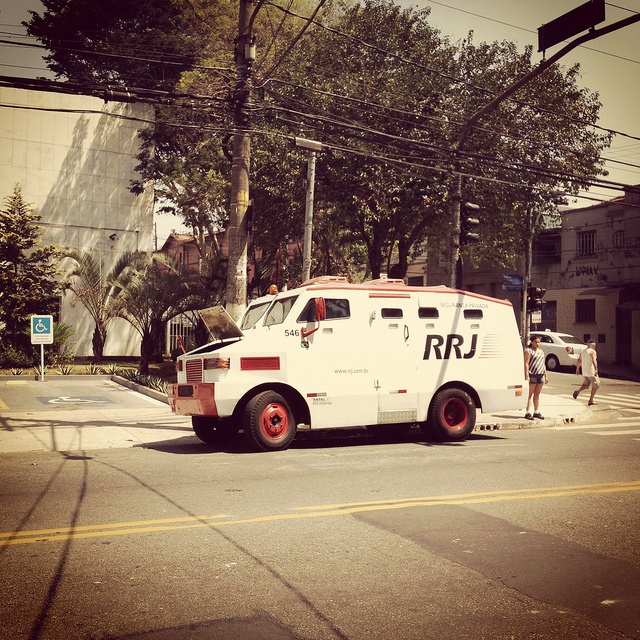Describe the objects in this image and their specific colors. I can see truck in gray, beige, black, tan, and maroon tones, car in gray, tan, beige, and black tones, people in gray, brown, beige, maroon, and tan tones, people in gray, tan, brown, and maroon tones, and traffic light in gray, black, and tan tones in this image. 